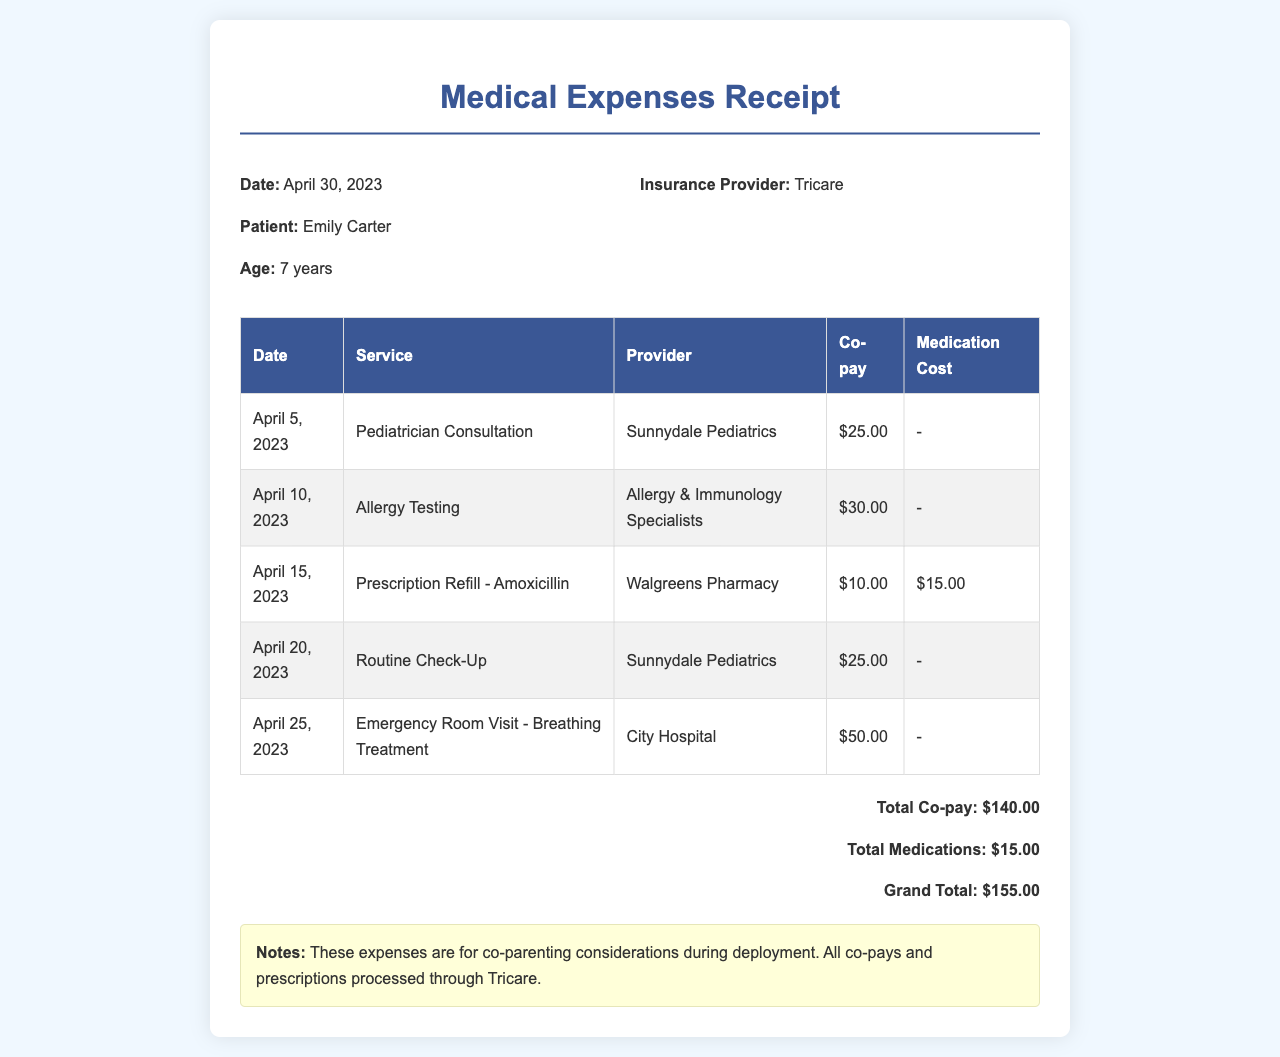What is the date of the receipt? The date of the receipt is specified prominently at the top, which is April 30, 2023.
Answer: April 30, 2023 Who is the patient? The patient's name is clearly mentioned in the document as Emily Carter.
Answer: Emily Carter What was the total co-pay amount? The total co-pay amount is summed from all individual co-pays listed, totaling $140.00.
Answer: $140.00 What medication is listed on the prescription? The document details a prescription refill for Amoxicillin specifically.
Answer: Amoxicillin How much was the co-pay for the Emergency Room Visit? The document shows the co-pay for the Emergency Room Visit as $50.00.
Answer: $50.00 How many services are listed on the receipt? By counting the rows in the service table, there are a total of five services documented.
Answer: 5 What is the Grand Total for the expenses? The Grand Total is provided at the bottom of the document, which combines co-pays and medication costs, totaling $155.00.
Answer: $155.00 Which insurance provider is listed? The document specifies that the insurance provider is Tricare.
Answer: Tricare What type of service was received on April 10, 2023? The service received on this date was Allergy Testing as noted in the document.
Answer: Allergy Testing 